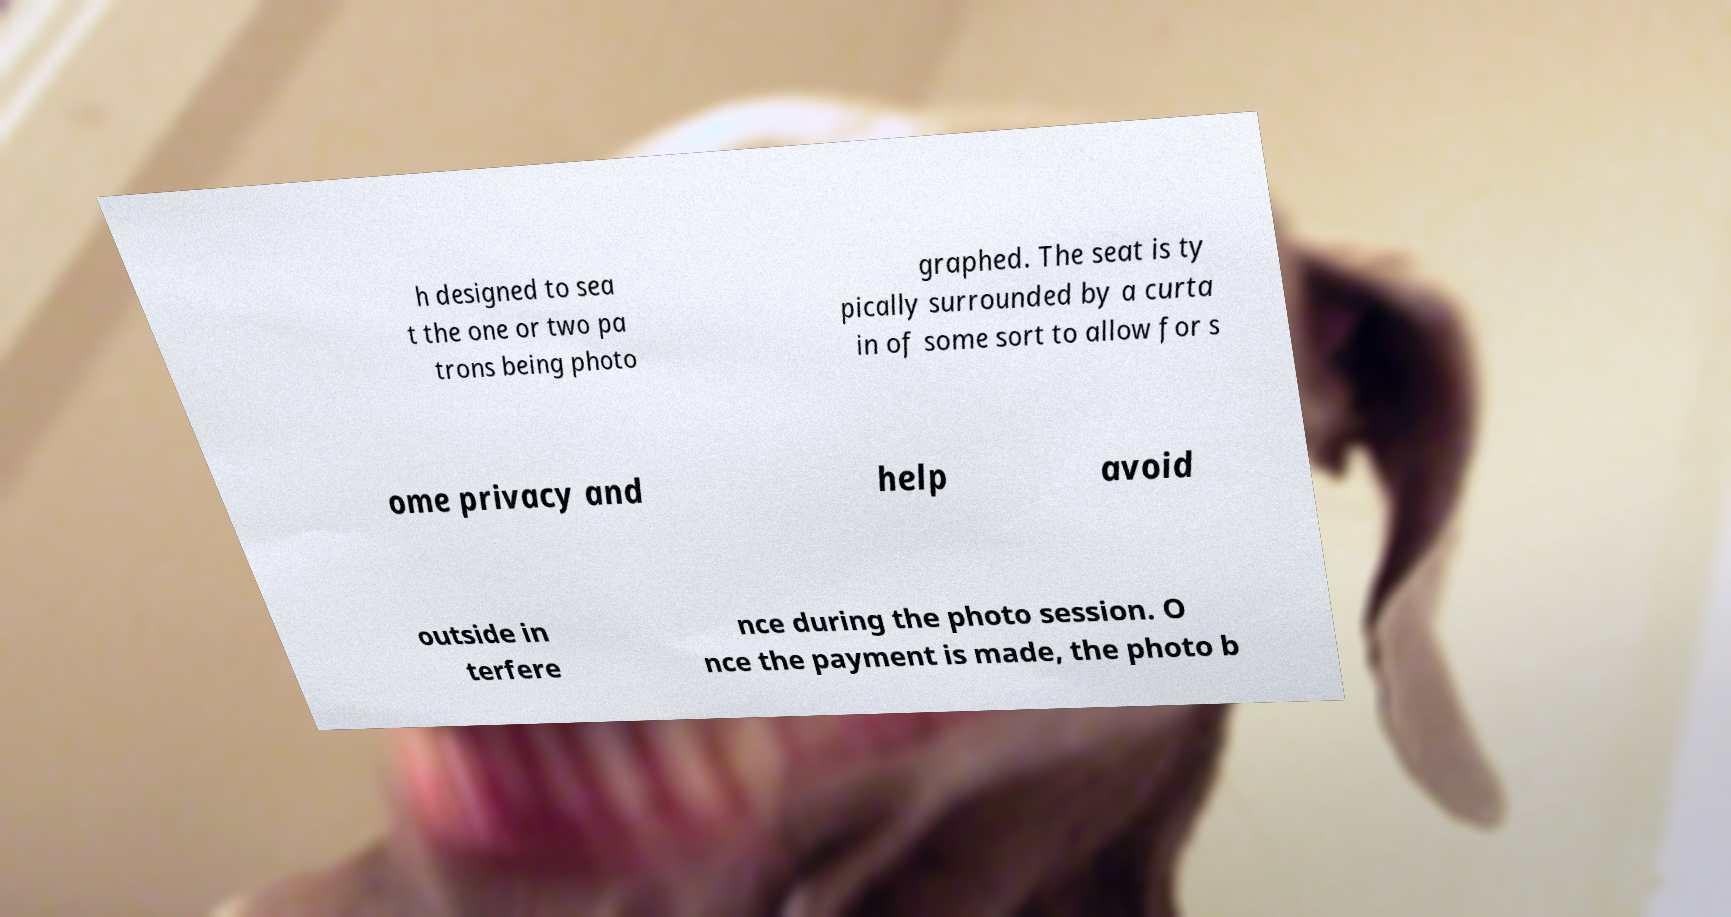I need the written content from this picture converted into text. Can you do that? h designed to sea t the one or two pa trons being photo graphed. The seat is ty pically surrounded by a curta in of some sort to allow for s ome privacy and help avoid outside in terfere nce during the photo session. O nce the payment is made, the photo b 